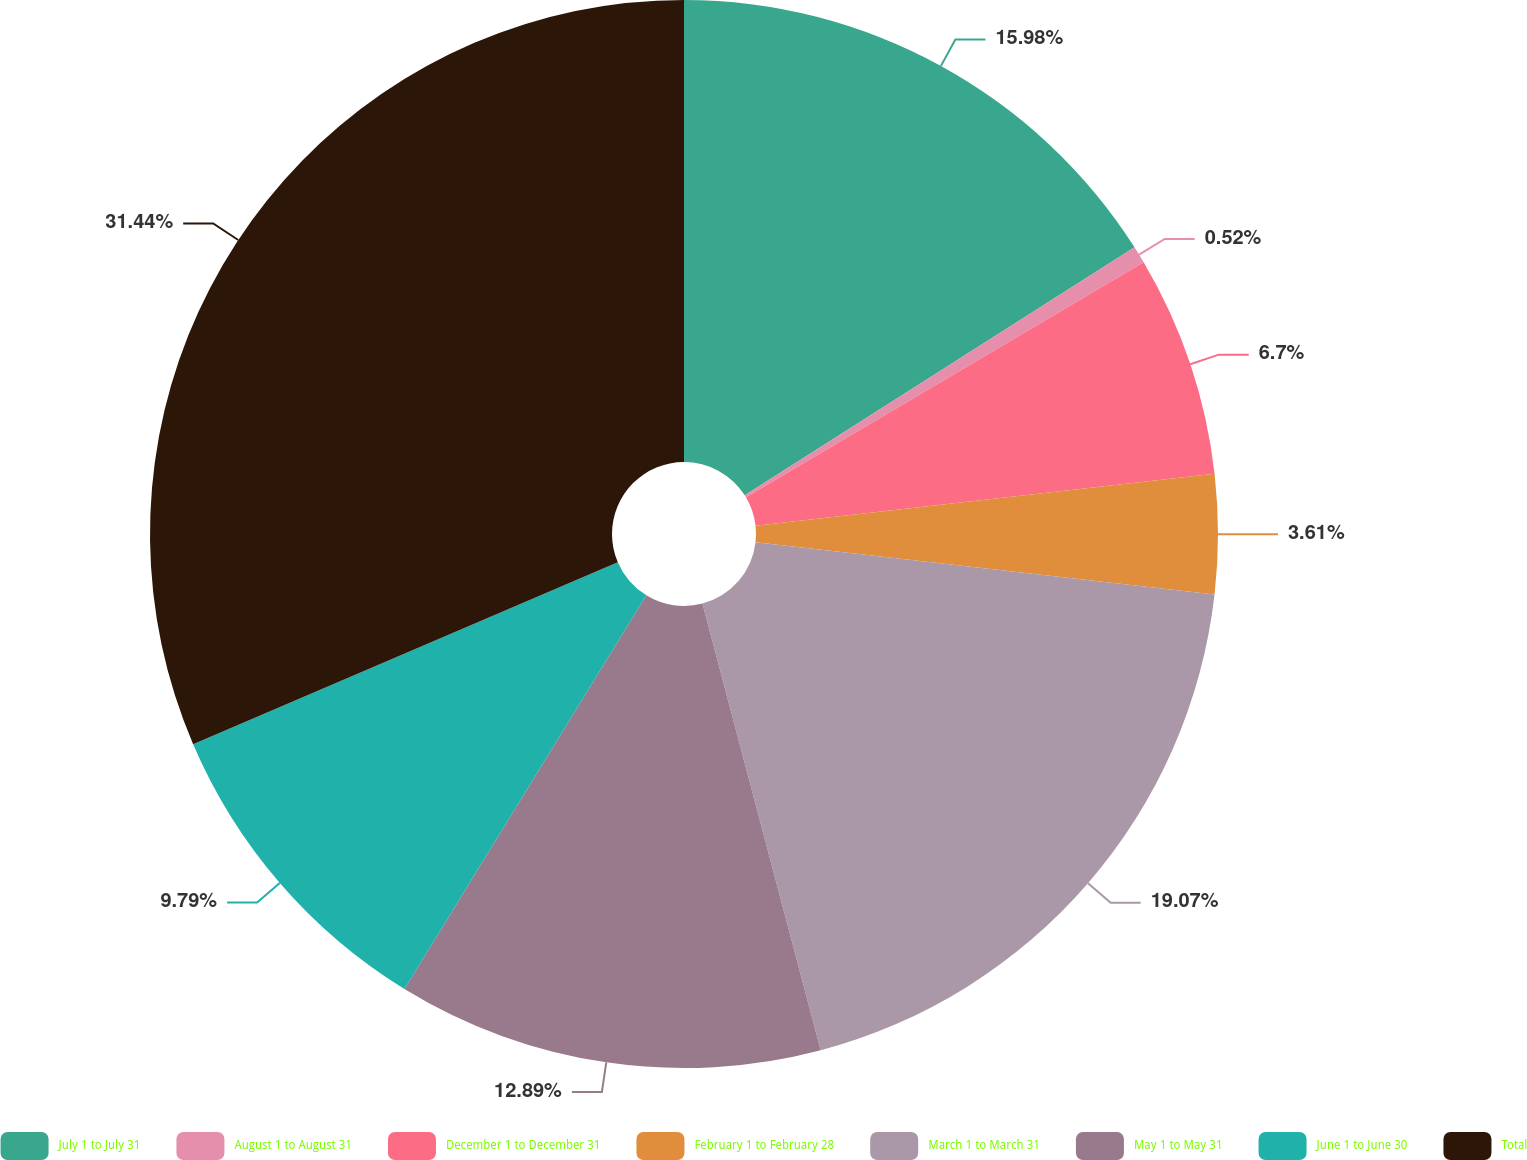Convert chart. <chart><loc_0><loc_0><loc_500><loc_500><pie_chart><fcel>July 1 to July 31<fcel>August 1 to August 31<fcel>December 1 to December 31<fcel>February 1 to February 28<fcel>March 1 to March 31<fcel>May 1 to May 31<fcel>June 1 to June 30<fcel>Total<nl><fcel>15.98%<fcel>0.52%<fcel>6.7%<fcel>3.61%<fcel>19.07%<fcel>12.89%<fcel>9.79%<fcel>31.44%<nl></chart> 